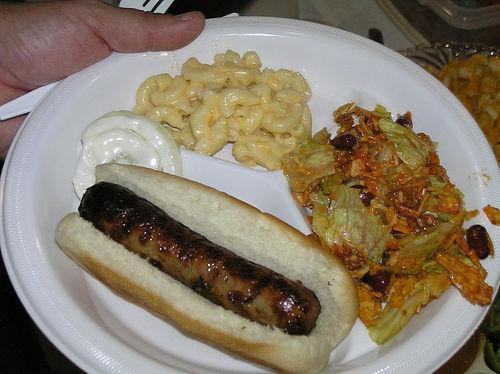How many orange lights can you see on the motorcycle?
Give a very brief answer. 0. 